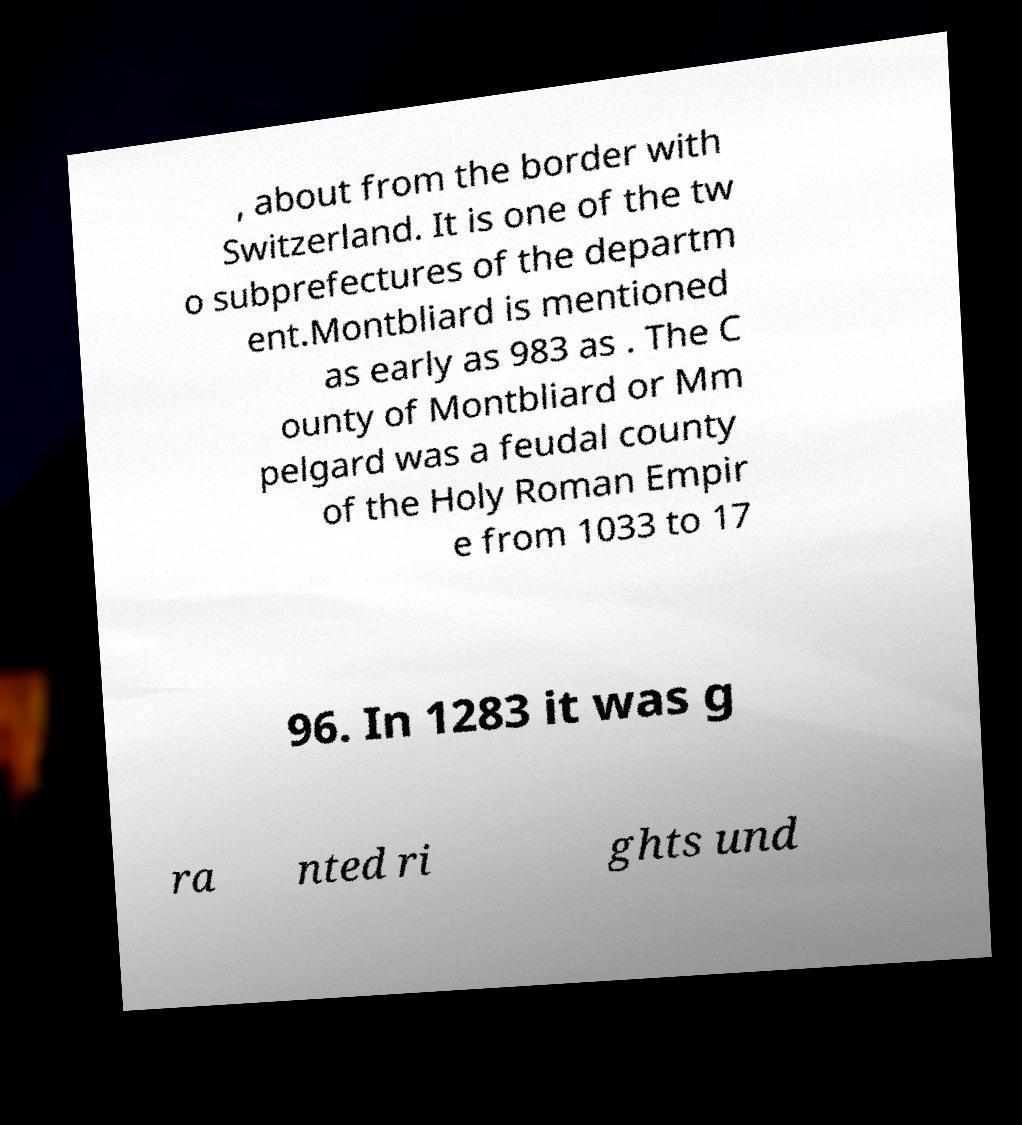Could you extract and type out the text from this image? , about from the border with Switzerland. It is one of the tw o subprefectures of the departm ent.Montbliard is mentioned as early as 983 as . The C ounty of Montbliard or Mm pelgard was a feudal county of the Holy Roman Empir e from 1033 to 17 96. In 1283 it was g ra nted ri ghts und 